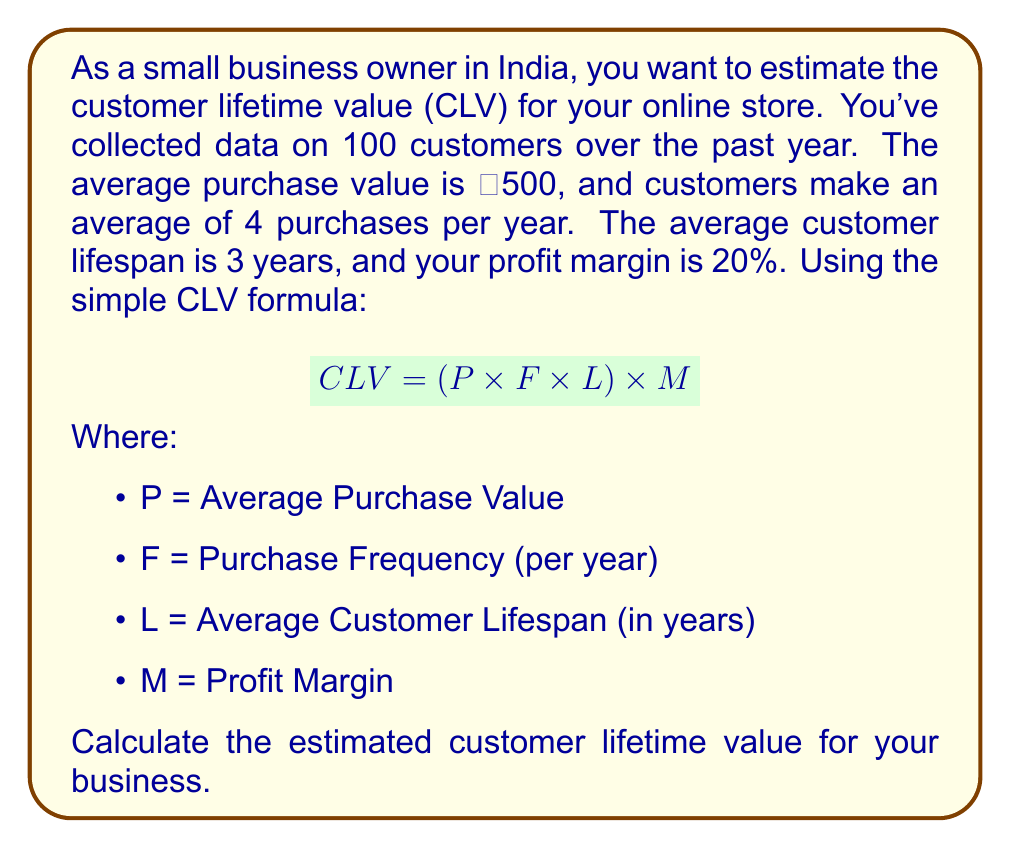Provide a solution to this math problem. To solve this problem, we'll use the given CLV formula and plug in the values provided:

1. Average Purchase Value (P): ₹500
2. Purchase Frequency (F): 4 purchases per year
3. Average Customer Lifespan (L): 3 years
4. Profit Margin (M): 20% or 0.20

Let's substitute these values into the formula:

$$ CLV = (P \times F \times L) \times M $$
$$ CLV = (₹500 \times 4 \times 3) \times 0.20 $$

Now, let's solve step by step:

1. First, multiply the values inside the parentheses:
   $$ (₹500 \times 4 \times 3) = ₹6,000 $$

2. Then, multiply the result by the profit margin:
   $$ ₹6,000 \times 0.20 = ₹1,200 $$

Therefore, the estimated customer lifetime value for your business is ₹1,200.
Answer: ₹1,200 